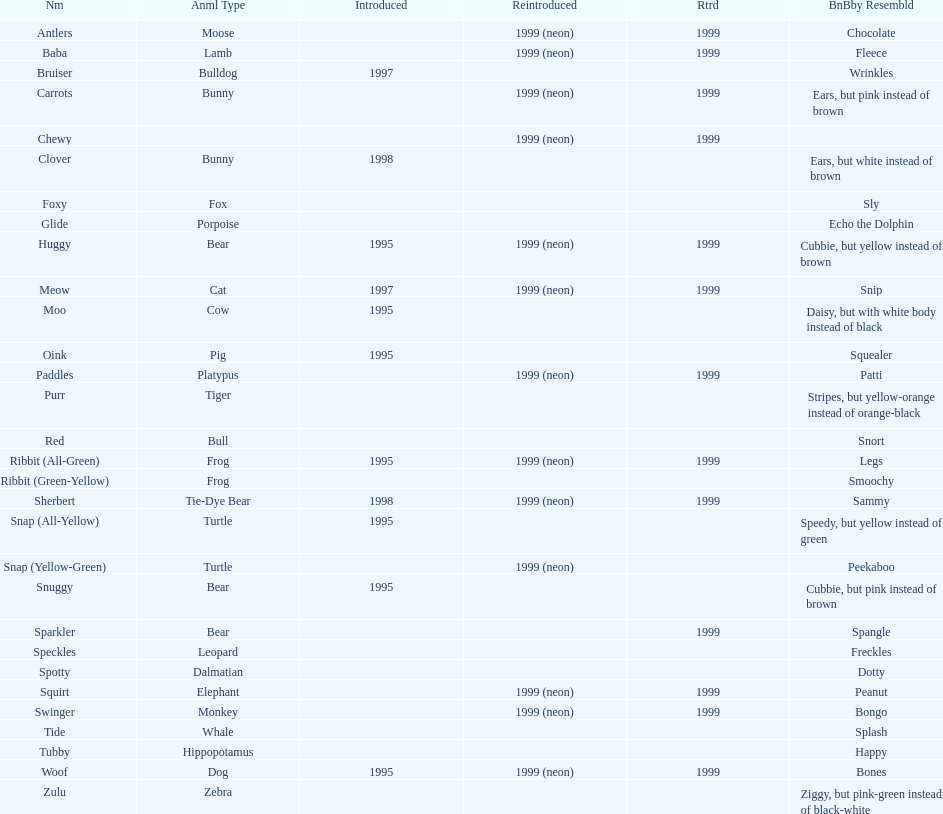In what year were the first pillow pals introduced? 1995. 